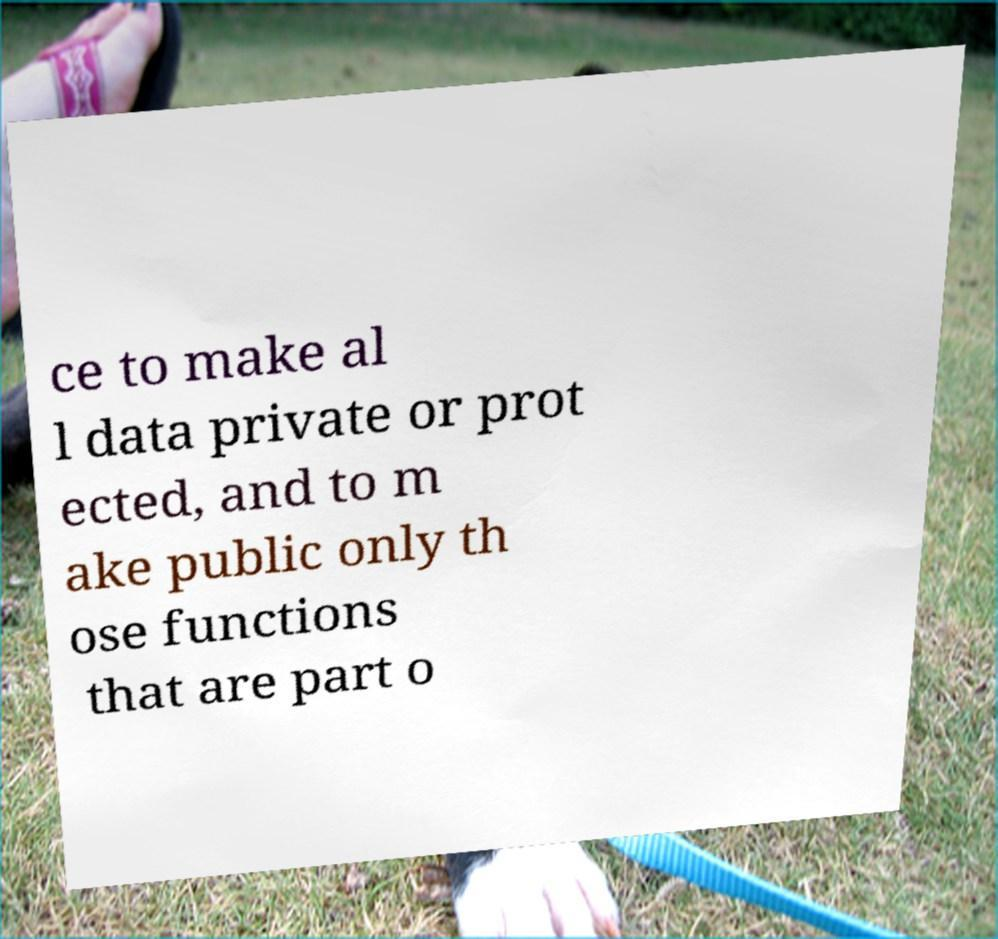For documentation purposes, I need the text within this image transcribed. Could you provide that? ce to make al l data private or prot ected, and to m ake public only th ose functions that are part o 